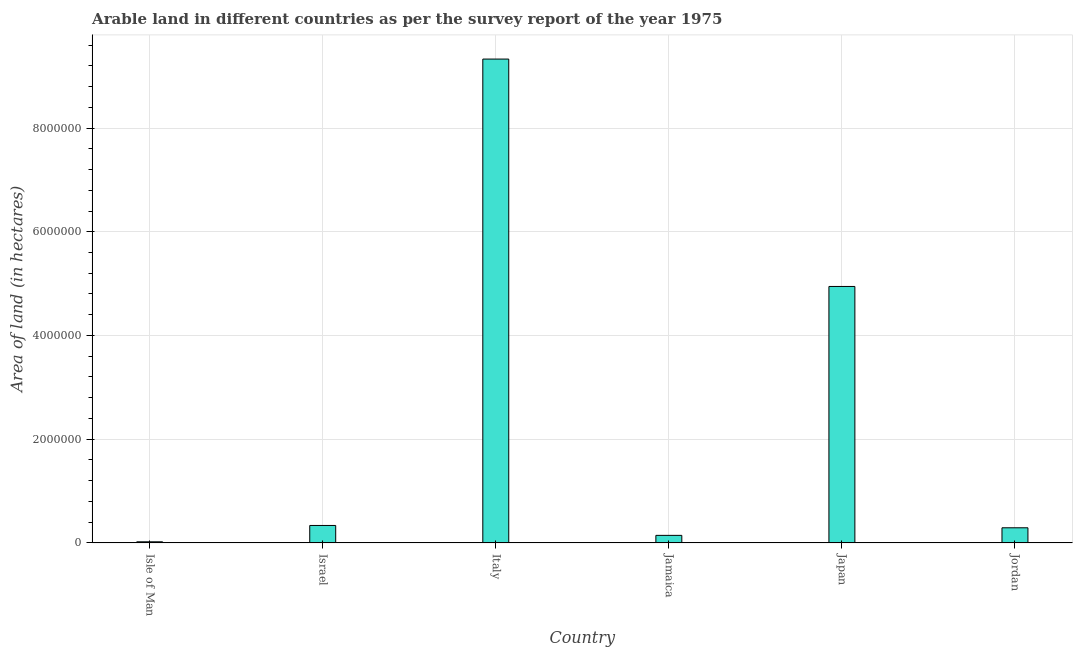Does the graph contain grids?
Keep it short and to the point. Yes. What is the title of the graph?
Give a very brief answer. Arable land in different countries as per the survey report of the year 1975. What is the label or title of the Y-axis?
Provide a succinct answer. Area of land (in hectares). What is the area of land in Jordan?
Keep it short and to the point. 2.91e+05. Across all countries, what is the maximum area of land?
Your answer should be compact. 9.33e+06. Across all countries, what is the minimum area of land?
Give a very brief answer. 2.09e+04. In which country was the area of land minimum?
Your answer should be compact. Isle of Man. What is the sum of the area of land?
Ensure brevity in your answer.  1.51e+07. What is the difference between the area of land in Israel and Jordan?
Provide a succinct answer. 4.50e+04. What is the average area of land per country?
Offer a terse response. 2.51e+06. What is the median area of land?
Provide a succinct answer. 3.14e+05. In how many countries, is the area of land greater than 1600000 hectares?
Ensure brevity in your answer.  2. What is the ratio of the area of land in Jamaica to that in Japan?
Make the answer very short. 0.03. Is the area of land in Isle of Man less than that in Jamaica?
Ensure brevity in your answer.  Yes. Is the difference between the area of land in Isle of Man and Jamaica greater than the difference between any two countries?
Make the answer very short. No. What is the difference between the highest and the second highest area of land?
Your answer should be compact. 4.38e+06. Is the sum of the area of land in Isle of Man and Israel greater than the maximum area of land across all countries?
Offer a terse response. No. What is the difference between the highest and the lowest area of land?
Keep it short and to the point. 9.31e+06. Are all the bars in the graph horizontal?
Provide a short and direct response. No. How many countries are there in the graph?
Your answer should be very brief. 6. What is the difference between two consecutive major ticks on the Y-axis?
Provide a short and direct response. 2.00e+06. What is the Area of land (in hectares) of Isle of Man?
Provide a short and direct response. 2.09e+04. What is the Area of land (in hectares) in Israel?
Keep it short and to the point. 3.36e+05. What is the Area of land (in hectares) of Italy?
Keep it short and to the point. 9.33e+06. What is the Area of land (in hectares) in Jamaica?
Make the answer very short. 1.45e+05. What is the Area of land (in hectares) of Japan?
Make the answer very short. 4.94e+06. What is the Area of land (in hectares) in Jordan?
Ensure brevity in your answer.  2.91e+05. What is the difference between the Area of land (in hectares) in Isle of Man and Israel?
Keep it short and to the point. -3.15e+05. What is the difference between the Area of land (in hectares) in Isle of Man and Italy?
Provide a succinct answer. -9.31e+06. What is the difference between the Area of land (in hectares) in Isle of Man and Jamaica?
Make the answer very short. -1.24e+05. What is the difference between the Area of land (in hectares) in Isle of Man and Japan?
Give a very brief answer. -4.92e+06. What is the difference between the Area of land (in hectares) in Isle of Man and Jordan?
Provide a succinct answer. -2.70e+05. What is the difference between the Area of land (in hectares) in Israel and Italy?
Provide a succinct answer. -8.99e+06. What is the difference between the Area of land (in hectares) in Israel and Jamaica?
Provide a short and direct response. 1.91e+05. What is the difference between the Area of land (in hectares) in Israel and Japan?
Your answer should be very brief. -4.61e+06. What is the difference between the Area of land (in hectares) in Israel and Jordan?
Ensure brevity in your answer.  4.50e+04. What is the difference between the Area of land (in hectares) in Italy and Jamaica?
Provide a succinct answer. 9.18e+06. What is the difference between the Area of land (in hectares) in Italy and Japan?
Your answer should be very brief. 4.38e+06. What is the difference between the Area of land (in hectares) in Italy and Jordan?
Offer a very short reply. 9.04e+06. What is the difference between the Area of land (in hectares) in Jamaica and Japan?
Offer a very short reply. -4.80e+06. What is the difference between the Area of land (in hectares) in Jamaica and Jordan?
Give a very brief answer. -1.46e+05. What is the difference between the Area of land (in hectares) in Japan and Jordan?
Offer a terse response. 4.65e+06. What is the ratio of the Area of land (in hectares) in Isle of Man to that in Israel?
Ensure brevity in your answer.  0.06. What is the ratio of the Area of land (in hectares) in Isle of Man to that in Italy?
Make the answer very short. 0. What is the ratio of the Area of land (in hectares) in Isle of Man to that in Jamaica?
Your response must be concise. 0.14. What is the ratio of the Area of land (in hectares) in Isle of Man to that in Japan?
Make the answer very short. 0. What is the ratio of the Area of land (in hectares) in Isle of Man to that in Jordan?
Provide a short and direct response. 0.07. What is the ratio of the Area of land (in hectares) in Israel to that in Italy?
Your answer should be compact. 0.04. What is the ratio of the Area of land (in hectares) in Israel to that in Jamaica?
Your response must be concise. 2.32. What is the ratio of the Area of land (in hectares) in Israel to that in Japan?
Offer a terse response. 0.07. What is the ratio of the Area of land (in hectares) in Israel to that in Jordan?
Offer a terse response. 1.16. What is the ratio of the Area of land (in hectares) in Italy to that in Jamaica?
Your answer should be very brief. 64.34. What is the ratio of the Area of land (in hectares) in Italy to that in Japan?
Your answer should be compact. 1.89. What is the ratio of the Area of land (in hectares) in Italy to that in Jordan?
Offer a very short reply. 32.06. What is the ratio of the Area of land (in hectares) in Jamaica to that in Japan?
Give a very brief answer. 0.03. What is the ratio of the Area of land (in hectares) in Jamaica to that in Jordan?
Provide a short and direct response. 0.5. What is the ratio of the Area of land (in hectares) in Japan to that in Jordan?
Make the answer very short. 16.99. 